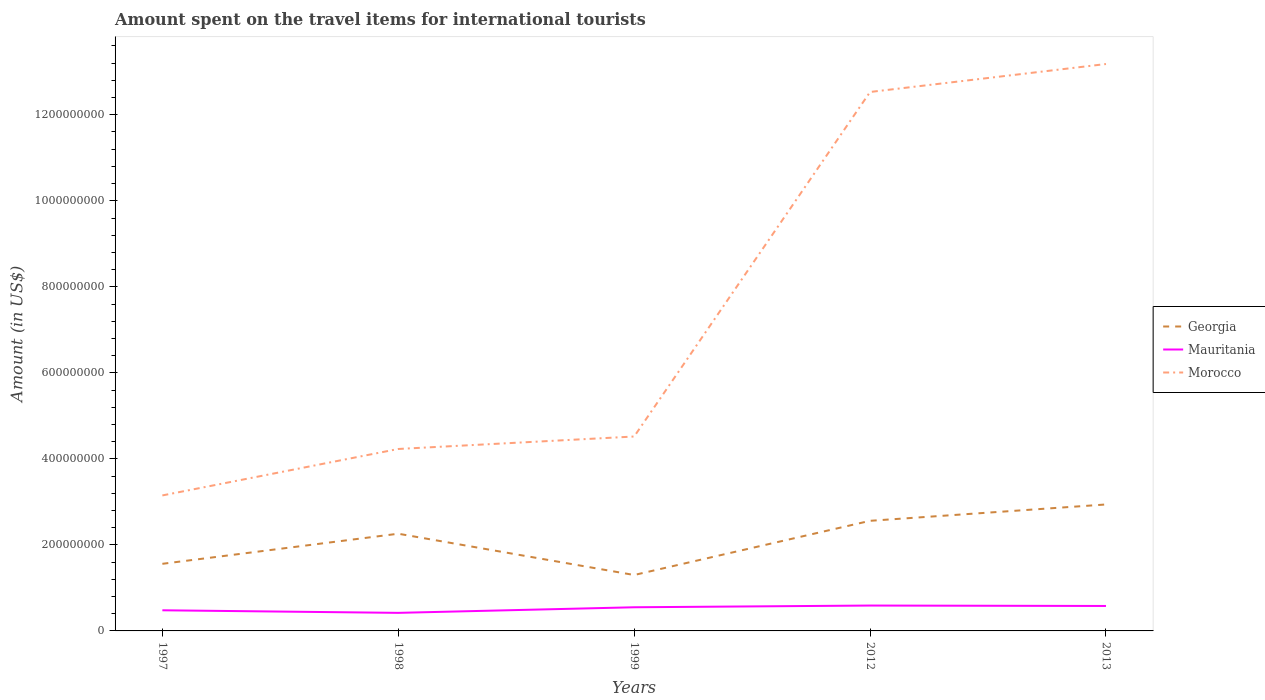Does the line corresponding to Morocco intersect with the line corresponding to Georgia?
Provide a succinct answer. No. Is the number of lines equal to the number of legend labels?
Make the answer very short. Yes. Across all years, what is the maximum amount spent on the travel items for international tourists in Mauritania?
Provide a succinct answer. 4.20e+07. In which year was the amount spent on the travel items for international tourists in Morocco maximum?
Your response must be concise. 1997. What is the difference between the highest and the second highest amount spent on the travel items for international tourists in Morocco?
Offer a very short reply. 1.00e+09. What is the difference between the highest and the lowest amount spent on the travel items for international tourists in Morocco?
Keep it short and to the point. 2. Are the values on the major ticks of Y-axis written in scientific E-notation?
Give a very brief answer. No. Does the graph contain any zero values?
Your response must be concise. No. How many legend labels are there?
Offer a very short reply. 3. What is the title of the graph?
Ensure brevity in your answer.  Amount spent on the travel items for international tourists. What is the label or title of the X-axis?
Ensure brevity in your answer.  Years. What is the Amount (in US$) of Georgia in 1997?
Make the answer very short. 1.56e+08. What is the Amount (in US$) in Mauritania in 1997?
Provide a short and direct response. 4.80e+07. What is the Amount (in US$) of Morocco in 1997?
Make the answer very short. 3.15e+08. What is the Amount (in US$) of Georgia in 1998?
Your answer should be very brief. 2.26e+08. What is the Amount (in US$) in Mauritania in 1998?
Make the answer very short. 4.20e+07. What is the Amount (in US$) of Morocco in 1998?
Give a very brief answer. 4.23e+08. What is the Amount (in US$) in Georgia in 1999?
Keep it short and to the point. 1.30e+08. What is the Amount (in US$) of Mauritania in 1999?
Your answer should be very brief. 5.50e+07. What is the Amount (in US$) of Morocco in 1999?
Provide a succinct answer. 4.52e+08. What is the Amount (in US$) in Georgia in 2012?
Ensure brevity in your answer.  2.56e+08. What is the Amount (in US$) in Mauritania in 2012?
Ensure brevity in your answer.  5.90e+07. What is the Amount (in US$) of Morocco in 2012?
Give a very brief answer. 1.25e+09. What is the Amount (in US$) of Georgia in 2013?
Provide a succinct answer. 2.94e+08. What is the Amount (in US$) of Mauritania in 2013?
Your answer should be very brief. 5.80e+07. What is the Amount (in US$) of Morocco in 2013?
Ensure brevity in your answer.  1.32e+09. Across all years, what is the maximum Amount (in US$) of Georgia?
Provide a succinct answer. 2.94e+08. Across all years, what is the maximum Amount (in US$) in Mauritania?
Your answer should be very brief. 5.90e+07. Across all years, what is the maximum Amount (in US$) in Morocco?
Offer a very short reply. 1.32e+09. Across all years, what is the minimum Amount (in US$) in Georgia?
Keep it short and to the point. 1.30e+08. Across all years, what is the minimum Amount (in US$) in Mauritania?
Your response must be concise. 4.20e+07. Across all years, what is the minimum Amount (in US$) of Morocco?
Offer a very short reply. 3.15e+08. What is the total Amount (in US$) in Georgia in the graph?
Offer a terse response. 1.06e+09. What is the total Amount (in US$) in Mauritania in the graph?
Offer a terse response. 2.62e+08. What is the total Amount (in US$) in Morocco in the graph?
Provide a short and direct response. 3.76e+09. What is the difference between the Amount (in US$) of Georgia in 1997 and that in 1998?
Make the answer very short. -7.00e+07. What is the difference between the Amount (in US$) in Mauritania in 1997 and that in 1998?
Your answer should be very brief. 6.00e+06. What is the difference between the Amount (in US$) in Morocco in 1997 and that in 1998?
Offer a very short reply. -1.08e+08. What is the difference between the Amount (in US$) of Georgia in 1997 and that in 1999?
Ensure brevity in your answer.  2.60e+07. What is the difference between the Amount (in US$) of Mauritania in 1997 and that in 1999?
Make the answer very short. -7.00e+06. What is the difference between the Amount (in US$) of Morocco in 1997 and that in 1999?
Keep it short and to the point. -1.37e+08. What is the difference between the Amount (in US$) of Georgia in 1997 and that in 2012?
Provide a succinct answer. -1.00e+08. What is the difference between the Amount (in US$) of Mauritania in 1997 and that in 2012?
Keep it short and to the point. -1.10e+07. What is the difference between the Amount (in US$) in Morocco in 1997 and that in 2012?
Give a very brief answer. -9.38e+08. What is the difference between the Amount (in US$) of Georgia in 1997 and that in 2013?
Your response must be concise. -1.38e+08. What is the difference between the Amount (in US$) of Mauritania in 1997 and that in 2013?
Provide a short and direct response. -1.00e+07. What is the difference between the Amount (in US$) of Morocco in 1997 and that in 2013?
Your answer should be compact. -1.00e+09. What is the difference between the Amount (in US$) in Georgia in 1998 and that in 1999?
Your answer should be compact. 9.60e+07. What is the difference between the Amount (in US$) of Mauritania in 1998 and that in 1999?
Keep it short and to the point. -1.30e+07. What is the difference between the Amount (in US$) of Morocco in 1998 and that in 1999?
Provide a short and direct response. -2.90e+07. What is the difference between the Amount (in US$) in Georgia in 1998 and that in 2012?
Make the answer very short. -3.00e+07. What is the difference between the Amount (in US$) of Mauritania in 1998 and that in 2012?
Your answer should be compact. -1.70e+07. What is the difference between the Amount (in US$) of Morocco in 1998 and that in 2012?
Ensure brevity in your answer.  -8.30e+08. What is the difference between the Amount (in US$) of Georgia in 1998 and that in 2013?
Offer a terse response. -6.80e+07. What is the difference between the Amount (in US$) of Mauritania in 1998 and that in 2013?
Provide a succinct answer. -1.60e+07. What is the difference between the Amount (in US$) of Morocco in 1998 and that in 2013?
Offer a very short reply. -8.95e+08. What is the difference between the Amount (in US$) in Georgia in 1999 and that in 2012?
Give a very brief answer. -1.26e+08. What is the difference between the Amount (in US$) in Morocco in 1999 and that in 2012?
Ensure brevity in your answer.  -8.01e+08. What is the difference between the Amount (in US$) of Georgia in 1999 and that in 2013?
Your answer should be very brief. -1.64e+08. What is the difference between the Amount (in US$) of Morocco in 1999 and that in 2013?
Offer a very short reply. -8.66e+08. What is the difference between the Amount (in US$) in Georgia in 2012 and that in 2013?
Ensure brevity in your answer.  -3.80e+07. What is the difference between the Amount (in US$) in Mauritania in 2012 and that in 2013?
Give a very brief answer. 1.00e+06. What is the difference between the Amount (in US$) in Morocco in 2012 and that in 2013?
Offer a terse response. -6.50e+07. What is the difference between the Amount (in US$) of Georgia in 1997 and the Amount (in US$) of Mauritania in 1998?
Keep it short and to the point. 1.14e+08. What is the difference between the Amount (in US$) of Georgia in 1997 and the Amount (in US$) of Morocco in 1998?
Provide a short and direct response. -2.67e+08. What is the difference between the Amount (in US$) in Mauritania in 1997 and the Amount (in US$) in Morocco in 1998?
Your answer should be very brief. -3.75e+08. What is the difference between the Amount (in US$) of Georgia in 1997 and the Amount (in US$) of Mauritania in 1999?
Your response must be concise. 1.01e+08. What is the difference between the Amount (in US$) of Georgia in 1997 and the Amount (in US$) of Morocco in 1999?
Make the answer very short. -2.96e+08. What is the difference between the Amount (in US$) of Mauritania in 1997 and the Amount (in US$) of Morocco in 1999?
Offer a very short reply. -4.04e+08. What is the difference between the Amount (in US$) of Georgia in 1997 and the Amount (in US$) of Mauritania in 2012?
Provide a short and direct response. 9.70e+07. What is the difference between the Amount (in US$) of Georgia in 1997 and the Amount (in US$) of Morocco in 2012?
Offer a very short reply. -1.10e+09. What is the difference between the Amount (in US$) of Mauritania in 1997 and the Amount (in US$) of Morocco in 2012?
Your response must be concise. -1.20e+09. What is the difference between the Amount (in US$) of Georgia in 1997 and the Amount (in US$) of Mauritania in 2013?
Offer a very short reply. 9.80e+07. What is the difference between the Amount (in US$) in Georgia in 1997 and the Amount (in US$) in Morocco in 2013?
Ensure brevity in your answer.  -1.16e+09. What is the difference between the Amount (in US$) in Mauritania in 1997 and the Amount (in US$) in Morocco in 2013?
Make the answer very short. -1.27e+09. What is the difference between the Amount (in US$) in Georgia in 1998 and the Amount (in US$) in Mauritania in 1999?
Provide a succinct answer. 1.71e+08. What is the difference between the Amount (in US$) of Georgia in 1998 and the Amount (in US$) of Morocco in 1999?
Offer a terse response. -2.26e+08. What is the difference between the Amount (in US$) of Mauritania in 1998 and the Amount (in US$) of Morocco in 1999?
Your answer should be very brief. -4.10e+08. What is the difference between the Amount (in US$) in Georgia in 1998 and the Amount (in US$) in Mauritania in 2012?
Ensure brevity in your answer.  1.67e+08. What is the difference between the Amount (in US$) in Georgia in 1998 and the Amount (in US$) in Morocco in 2012?
Offer a very short reply. -1.03e+09. What is the difference between the Amount (in US$) of Mauritania in 1998 and the Amount (in US$) of Morocco in 2012?
Your answer should be very brief. -1.21e+09. What is the difference between the Amount (in US$) in Georgia in 1998 and the Amount (in US$) in Mauritania in 2013?
Your response must be concise. 1.68e+08. What is the difference between the Amount (in US$) in Georgia in 1998 and the Amount (in US$) in Morocco in 2013?
Offer a very short reply. -1.09e+09. What is the difference between the Amount (in US$) in Mauritania in 1998 and the Amount (in US$) in Morocco in 2013?
Make the answer very short. -1.28e+09. What is the difference between the Amount (in US$) in Georgia in 1999 and the Amount (in US$) in Mauritania in 2012?
Your answer should be compact. 7.10e+07. What is the difference between the Amount (in US$) in Georgia in 1999 and the Amount (in US$) in Morocco in 2012?
Give a very brief answer. -1.12e+09. What is the difference between the Amount (in US$) of Mauritania in 1999 and the Amount (in US$) of Morocco in 2012?
Give a very brief answer. -1.20e+09. What is the difference between the Amount (in US$) in Georgia in 1999 and the Amount (in US$) in Mauritania in 2013?
Your response must be concise. 7.20e+07. What is the difference between the Amount (in US$) in Georgia in 1999 and the Amount (in US$) in Morocco in 2013?
Keep it short and to the point. -1.19e+09. What is the difference between the Amount (in US$) in Mauritania in 1999 and the Amount (in US$) in Morocco in 2013?
Provide a succinct answer. -1.26e+09. What is the difference between the Amount (in US$) in Georgia in 2012 and the Amount (in US$) in Mauritania in 2013?
Give a very brief answer. 1.98e+08. What is the difference between the Amount (in US$) of Georgia in 2012 and the Amount (in US$) of Morocco in 2013?
Your response must be concise. -1.06e+09. What is the difference between the Amount (in US$) of Mauritania in 2012 and the Amount (in US$) of Morocco in 2013?
Your response must be concise. -1.26e+09. What is the average Amount (in US$) in Georgia per year?
Provide a succinct answer. 2.12e+08. What is the average Amount (in US$) in Mauritania per year?
Provide a short and direct response. 5.24e+07. What is the average Amount (in US$) in Morocco per year?
Offer a very short reply. 7.52e+08. In the year 1997, what is the difference between the Amount (in US$) in Georgia and Amount (in US$) in Mauritania?
Provide a succinct answer. 1.08e+08. In the year 1997, what is the difference between the Amount (in US$) of Georgia and Amount (in US$) of Morocco?
Provide a succinct answer. -1.59e+08. In the year 1997, what is the difference between the Amount (in US$) of Mauritania and Amount (in US$) of Morocco?
Your answer should be compact. -2.67e+08. In the year 1998, what is the difference between the Amount (in US$) of Georgia and Amount (in US$) of Mauritania?
Make the answer very short. 1.84e+08. In the year 1998, what is the difference between the Amount (in US$) in Georgia and Amount (in US$) in Morocco?
Your answer should be compact. -1.97e+08. In the year 1998, what is the difference between the Amount (in US$) in Mauritania and Amount (in US$) in Morocco?
Your answer should be very brief. -3.81e+08. In the year 1999, what is the difference between the Amount (in US$) of Georgia and Amount (in US$) of Mauritania?
Offer a terse response. 7.50e+07. In the year 1999, what is the difference between the Amount (in US$) in Georgia and Amount (in US$) in Morocco?
Give a very brief answer. -3.22e+08. In the year 1999, what is the difference between the Amount (in US$) in Mauritania and Amount (in US$) in Morocco?
Your response must be concise. -3.97e+08. In the year 2012, what is the difference between the Amount (in US$) of Georgia and Amount (in US$) of Mauritania?
Keep it short and to the point. 1.97e+08. In the year 2012, what is the difference between the Amount (in US$) of Georgia and Amount (in US$) of Morocco?
Your answer should be very brief. -9.97e+08. In the year 2012, what is the difference between the Amount (in US$) of Mauritania and Amount (in US$) of Morocco?
Your response must be concise. -1.19e+09. In the year 2013, what is the difference between the Amount (in US$) in Georgia and Amount (in US$) in Mauritania?
Offer a terse response. 2.36e+08. In the year 2013, what is the difference between the Amount (in US$) of Georgia and Amount (in US$) of Morocco?
Keep it short and to the point. -1.02e+09. In the year 2013, what is the difference between the Amount (in US$) of Mauritania and Amount (in US$) of Morocco?
Give a very brief answer. -1.26e+09. What is the ratio of the Amount (in US$) in Georgia in 1997 to that in 1998?
Give a very brief answer. 0.69. What is the ratio of the Amount (in US$) of Morocco in 1997 to that in 1998?
Provide a short and direct response. 0.74. What is the ratio of the Amount (in US$) in Mauritania in 1997 to that in 1999?
Keep it short and to the point. 0.87. What is the ratio of the Amount (in US$) of Morocco in 1997 to that in 1999?
Ensure brevity in your answer.  0.7. What is the ratio of the Amount (in US$) in Georgia in 1997 to that in 2012?
Keep it short and to the point. 0.61. What is the ratio of the Amount (in US$) of Mauritania in 1997 to that in 2012?
Your response must be concise. 0.81. What is the ratio of the Amount (in US$) in Morocco in 1997 to that in 2012?
Keep it short and to the point. 0.25. What is the ratio of the Amount (in US$) of Georgia in 1997 to that in 2013?
Ensure brevity in your answer.  0.53. What is the ratio of the Amount (in US$) in Mauritania in 1997 to that in 2013?
Make the answer very short. 0.83. What is the ratio of the Amount (in US$) of Morocco in 1997 to that in 2013?
Ensure brevity in your answer.  0.24. What is the ratio of the Amount (in US$) in Georgia in 1998 to that in 1999?
Make the answer very short. 1.74. What is the ratio of the Amount (in US$) in Mauritania in 1998 to that in 1999?
Make the answer very short. 0.76. What is the ratio of the Amount (in US$) of Morocco in 1998 to that in 1999?
Your answer should be very brief. 0.94. What is the ratio of the Amount (in US$) of Georgia in 1998 to that in 2012?
Your response must be concise. 0.88. What is the ratio of the Amount (in US$) in Mauritania in 1998 to that in 2012?
Provide a succinct answer. 0.71. What is the ratio of the Amount (in US$) in Morocco in 1998 to that in 2012?
Ensure brevity in your answer.  0.34. What is the ratio of the Amount (in US$) of Georgia in 1998 to that in 2013?
Offer a very short reply. 0.77. What is the ratio of the Amount (in US$) of Mauritania in 1998 to that in 2013?
Ensure brevity in your answer.  0.72. What is the ratio of the Amount (in US$) of Morocco in 1998 to that in 2013?
Offer a very short reply. 0.32. What is the ratio of the Amount (in US$) of Georgia in 1999 to that in 2012?
Offer a terse response. 0.51. What is the ratio of the Amount (in US$) in Mauritania in 1999 to that in 2012?
Offer a terse response. 0.93. What is the ratio of the Amount (in US$) in Morocco in 1999 to that in 2012?
Provide a short and direct response. 0.36. What is the ratio of the Amount (in US$) in Georgia in 1999 to that in 2013?
Your answer should be very brief. 0.44. What is the ratio of the Amount (in US$) in Mauritania in 1999 to that in 2013?
Make the answer very short. 0.95. What is the ratio of the Amount (in US$) of Morocco in 1999 to that in 2013?
Your answer should be compact. 0.34. What is the ratio of the Amount (in US$) of Georgia in 2012 to that in 2013?
Your answer should be compact. 0.87. What is the ratio of the Amount (in US$) of Mauritania in 2012 to that in 2013?
Your response must be concise. 1.02. What is the ratio of the Amount (in US$) in Morocco in 2012 to that in 2013?
Your answer should be very brief. 0.95. What is the difference between the highest and the second highest Amount (in US$) of Georgia?
Offer a very short reply. 3.80e+07. What is the difference between the highest and the second highest Amount (in US$) of Mauritania?
Give a very brief answer. 1.00e+06. What is the difference between the highest and the second highest Amount (in US$) in Morocco?
Ensure brevity in your answer.  6.50e+07. What is the difference between the highest and the lowest Amount (in US$) of Georgia?
Provide a short and direct response. 1.64e+08. What is the difference between the highest and the lowest Amount (in US$) in Mauritania?
Your answer should be very brief. 1.70e+07. What is the difference between the highest and the lowest Amount (in US$) of Morocco?
Make the answer very short. 1.00e+09. 